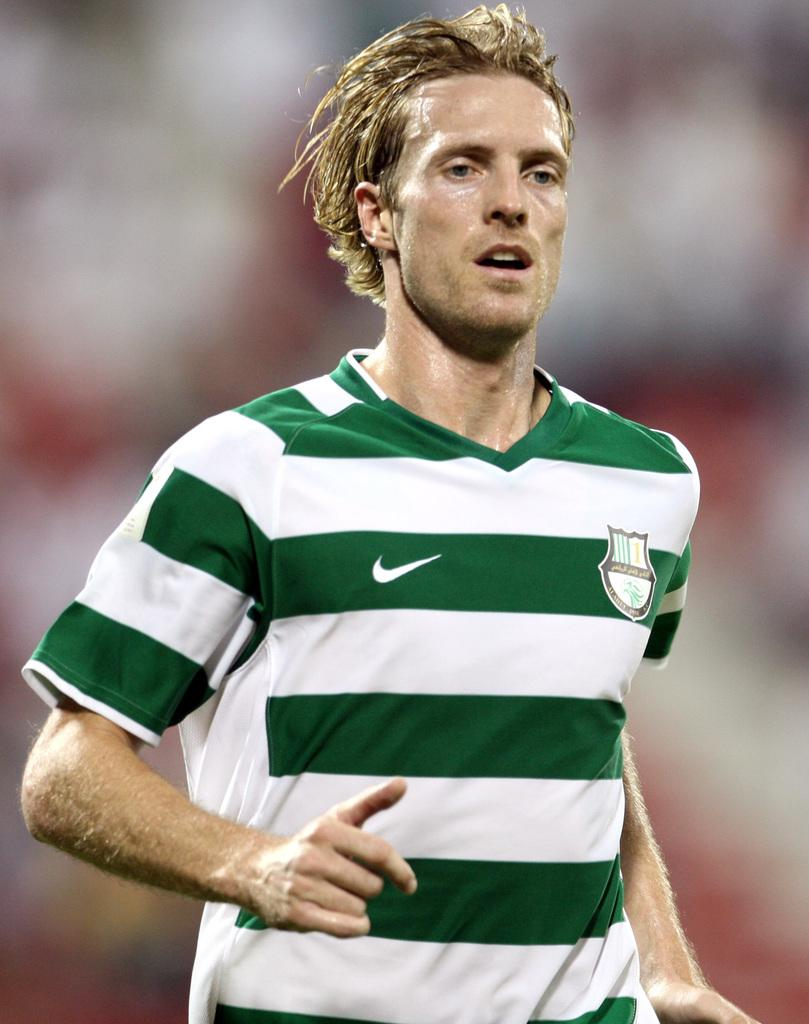What is the main subject of the image? There is a man in the image. What type of bone can be seen in the image? There is no bone present in the image; it features a man. How many chairs are visible in the image? There is no information about chairs in the image, as it only mentions a man. 